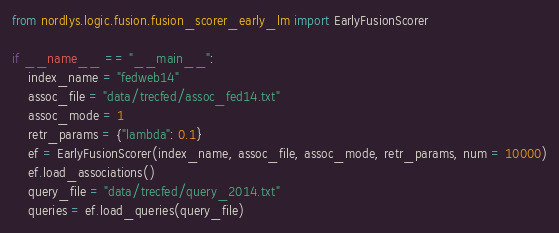Convert code to text. <code><loc_0><loc_0><loc_500><loc_500><_Python_>from nordlys.logic.fusion.fusion_scorer_early_lm import EarlyFusionScorer

if __name__ == "__main__":
    index_name = "fedweb14"
    assoc_file = "data/trecfed/assoc_fed14.txt"
    assoc_mode = 1
    retr_params = {"lambda": 0.1}
    ef = EarlyFusionScorer(index_name, assoc_file, assoc_mode, retr_params, num = 10000)
    ef.load_associations()
    query_file = "data/trecfed/query_2014.txt"
    queries = ef.load_queries(query_file)</code> 